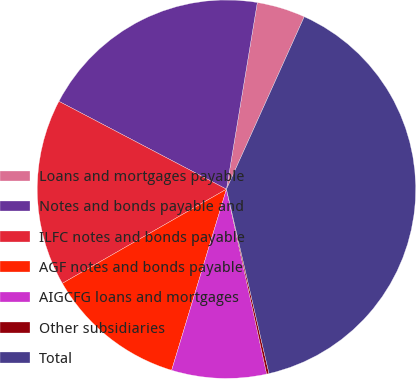<chart> <loc_0><loc_0><loc_500><loc_500><pie_chart><fcel>Loans and mortgages payable<fcel>Notes and bonds payable and<fcel>ILFC notes and bonds payable<fcel>AGF notes and bonds payable<fcel>AIGCFG loans and mortgages<fcel>Other subsidiaries<fcel>Total<nl><fcel>4.14%<fcel>19.92%<fcel>15.98%<fcel>12.03%<fcel>8.09%<fcel>0.2%<fcel>39.65%<nl></chart> 